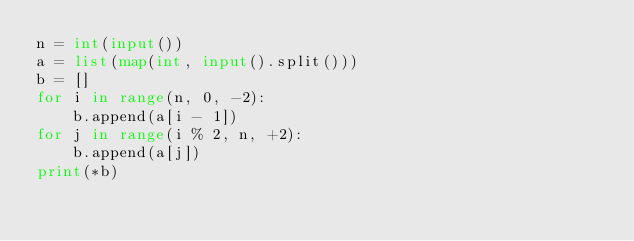Convert code to text. <code><loc_0><loc_0><loc_500><loc_500><_Python_>n = int(input())
a = list(map(int, input().split()))
b = []
for i in range(n, 0, -2):
    b.append(a[i - 1])
for j in range(i % 2, n, +2):
    b.append(a[j])
print(*b)
</code> 